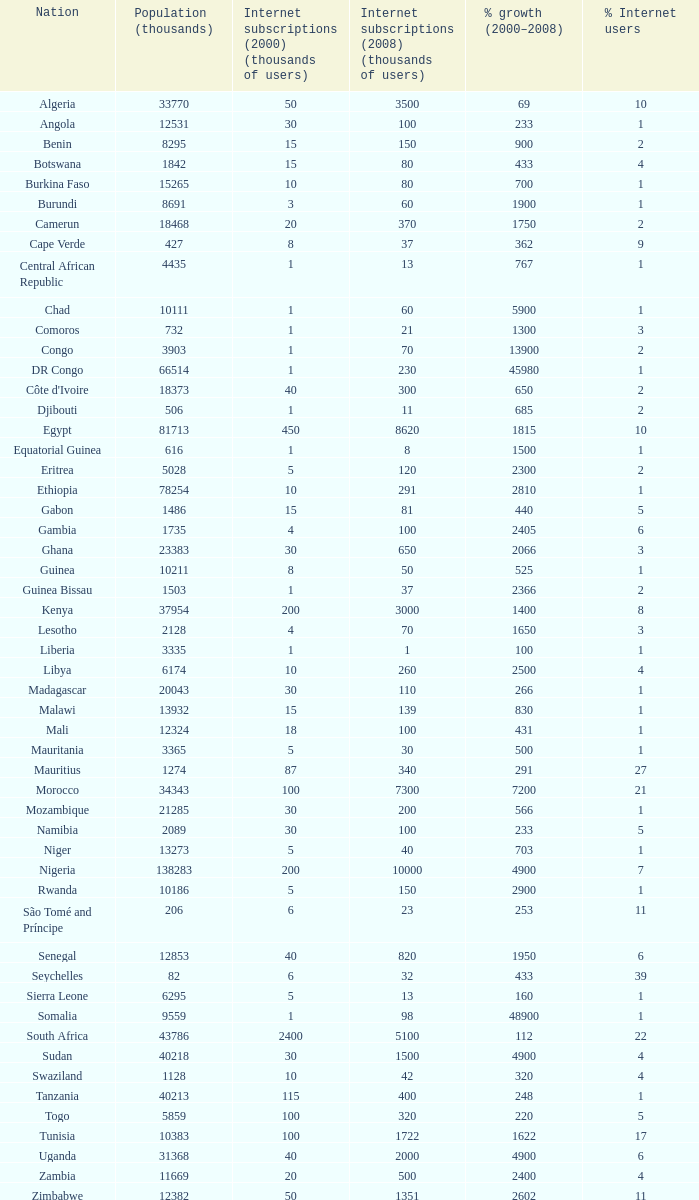What was the highest growth percentage in burundi between 2000 and 2008? 1900.0. 